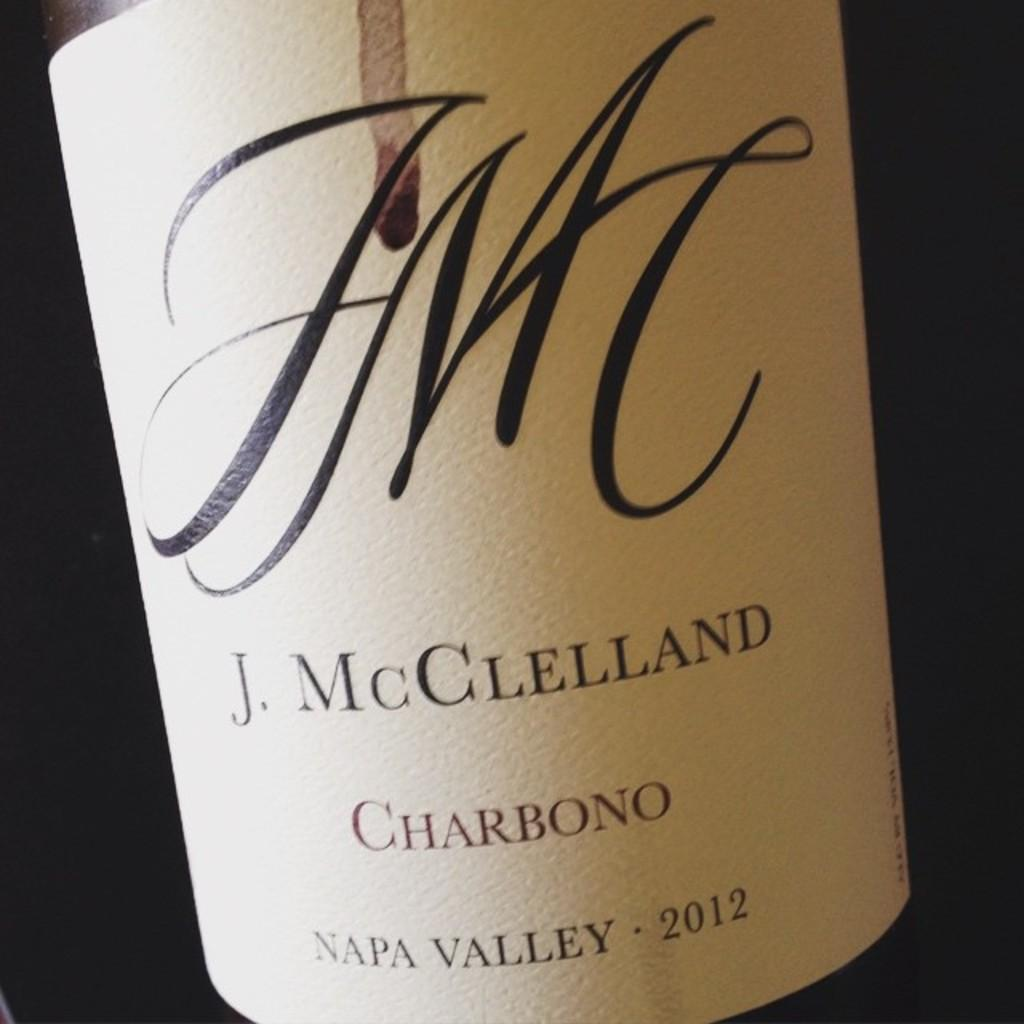<image>
Provide a brief description of the given image. a bottle of J. McGlelland from 2012 and made in napa vallet 